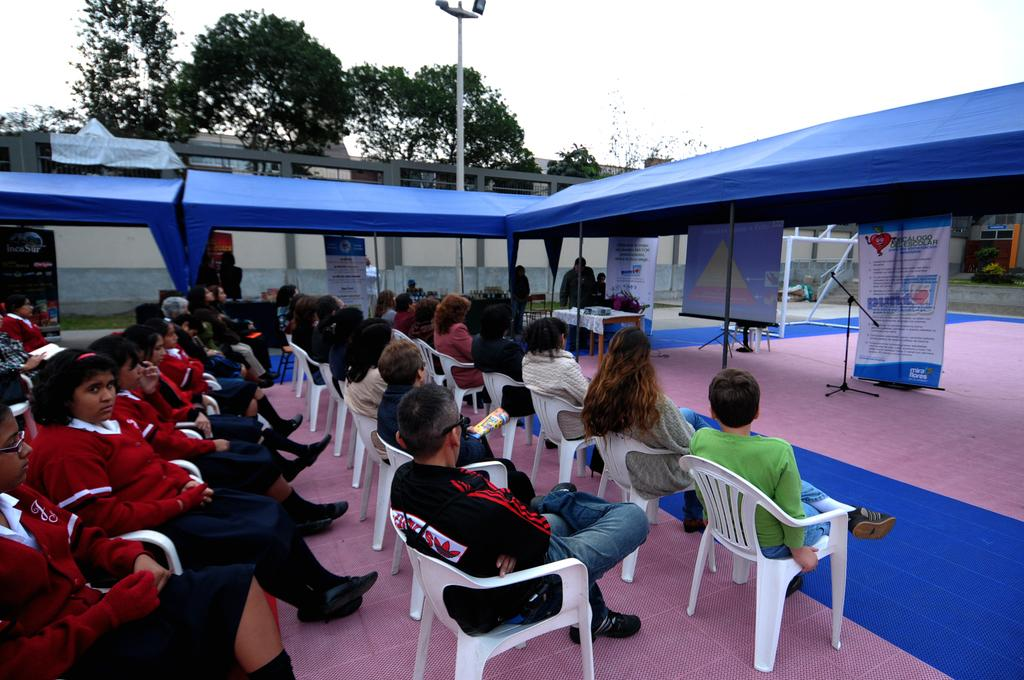What are the people in the image doing? The people in the image are sitting on chairs. What structure can be seen in the image? There is a tent in the image. What is visible in the background of the image? There is a wall, a pole, and trees in the background of the image. How many bananas are hanging from the pole in the image? There are no bananas present in the image; the pole is in the background without any bananas hanging from it. 